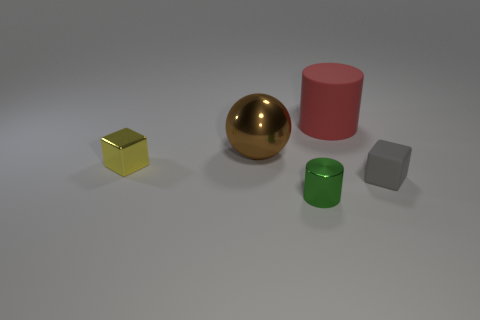Add 2 small green cylinders. How many objects exist? 7 Subtract 1 balls. How many balls are left? 0 Add 3 yellow blocks. How many yellow blocks exist? 4 Subtract all green cylinders. How many cylinders are left? 1 Subtract 1 brown balls. How many objects are left? 4 Subtract all cubes. How many objects are left? 3 Subtract all purple cylinders. Subtract all gray spheres. How many cylinders are left? 2 Subtract all green cylinders. How many gray blocks are left? 1 Subtract all tiny purple matte things. Subtract all tiny rubber blocks. How many objects are left? 4 Add 3 tiny rubber things. How many tiny rubber things are left? 4 